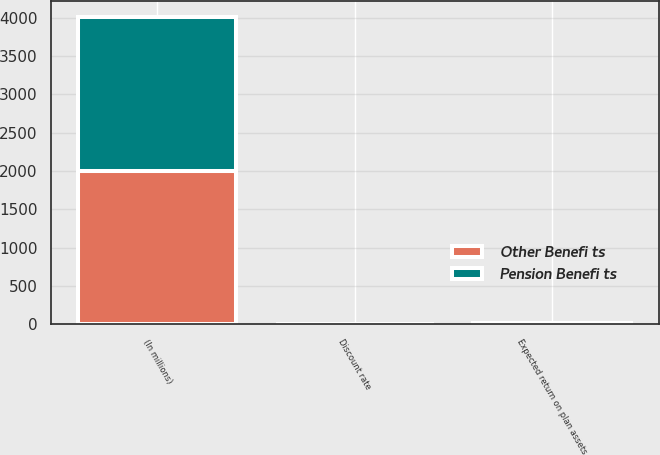Convert chart. <chart><loc_0><loc_0><loc_500><loc_500><stacked_bar_chart><ecel><fcel>(In millions)<fcel>Discount rate<fcel>Expected return on plan assets<nl><fcel>Pension Benefi ts<fcel>2007<fcel>5.86<fcel>8<nl><fcel>Other Benefi ts<fcel>2007<fcel>5.84<fcel>8<nl></chart> 